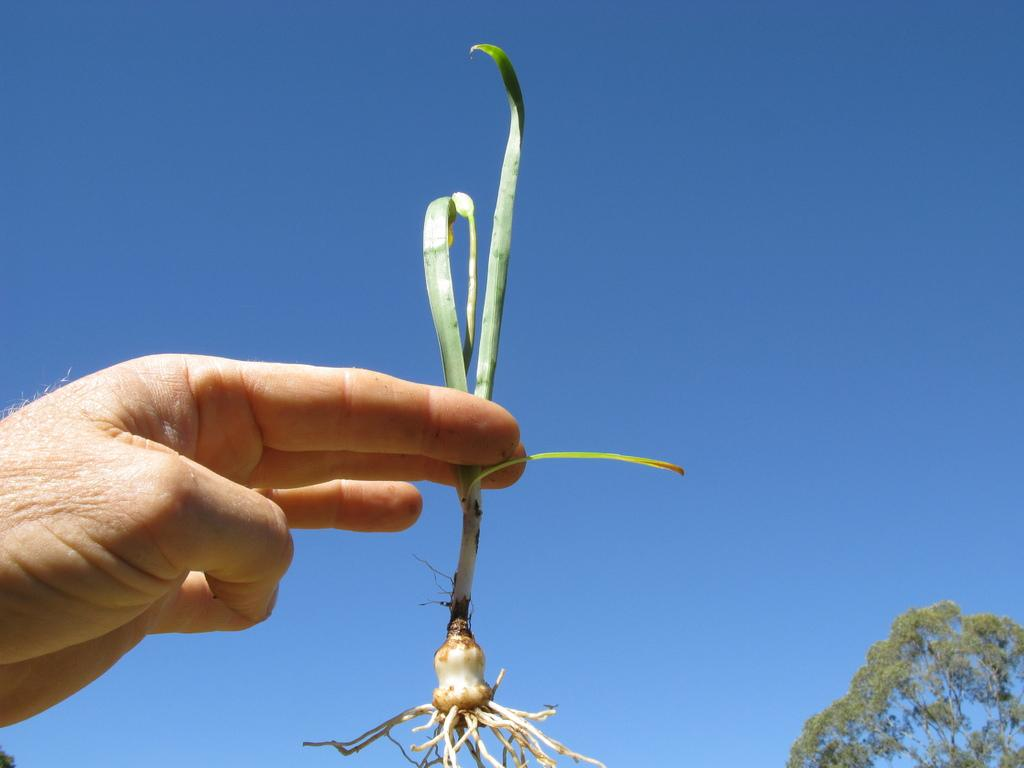What is the human hand holding in the image? The human hand is holding a plant in the image. Can you describe the plant being held? The plant has visible roots. What can be seen in the right side bottom corner of the image? There is a tree in the right side bottom corner of the image. What is visible in the background of the image? The background of the image features a clear sky. How does the owl expand its wings in the image? There is no owl present in the image, so it is not possible to answer that question. 